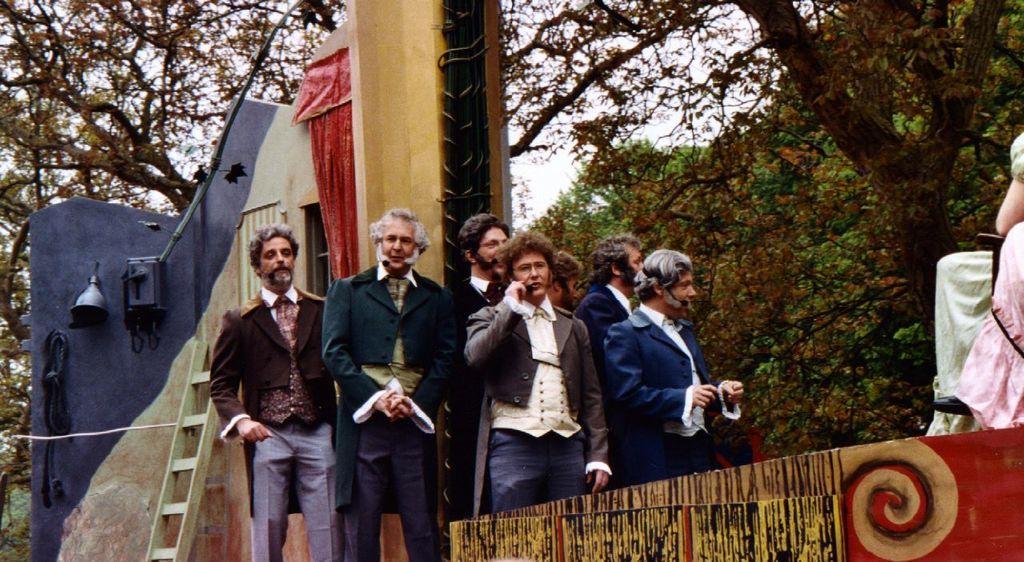Describe this image in one or two sentences. In this picture we can see a group of people, here we can see a fence, ladder, wall, window, curtain, bell and some objects and in the background we can see trees, sky. 